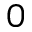Convert formula to latex. <formula><loc_0><loc_0><loc_500><loc_500>0</formula> 